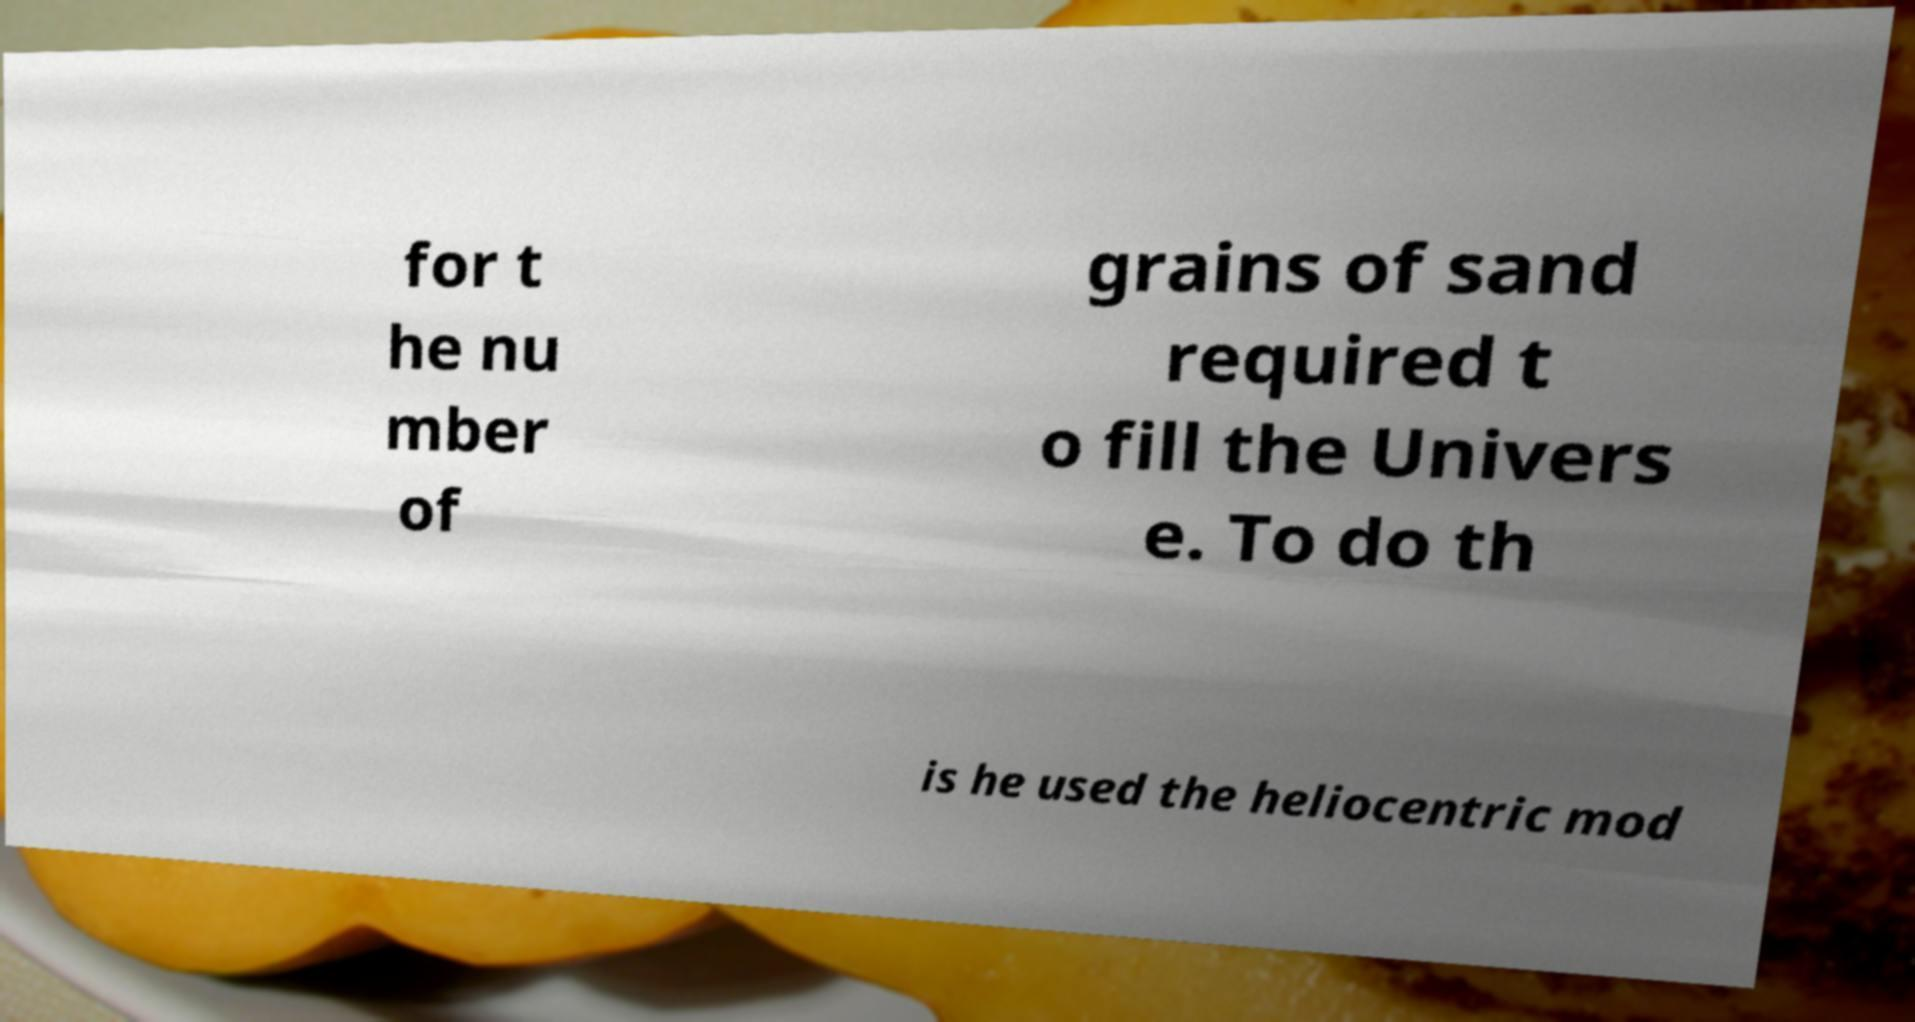Could you assist in decoding the text presented in this image and type it out clearly? for t he nu mber of grains of sand required t o fill the Univers e. To do th is he used the heliocentric mod 